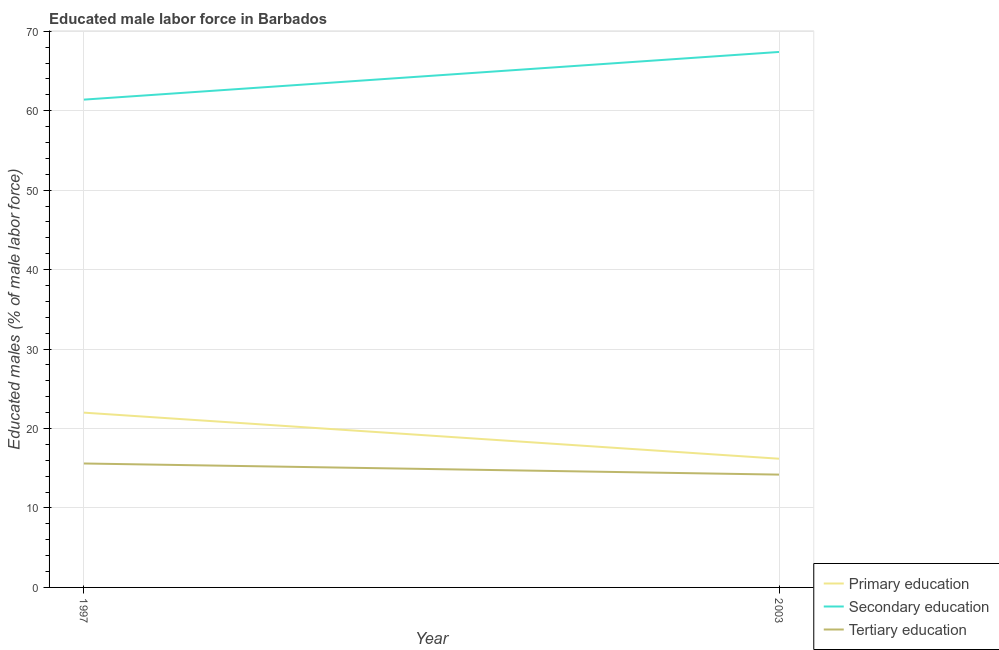Is the number of lines equal to the number of legend labels?
Your answer should be compact. Yes. What is the percentage of male labor force who received tertiary education in 2003?
Ensure brevity in your answer.  14.2. Across all years, what is the maximum percentage of male labor force who received tertiary education?
Your answer should be very brief. 15.6. Across all years, what is the minimum percentage of male labor force who received secondary education?
Your answer should be very brief. 61.4. What is the total percentage of male labor force who received tertiary education in the graph?
Give a very brief answer. 29.8. What is the difference between the percentage of male labor force who received tertiary education in 1997 and that in 2003?
Provide a short and direct response. 1.4. What is the difference between the percentage of male labor force who received secondary education in 1997 and the percentage of male labor force who received primary education in 2003?
Ensure brevity in your answer.  45.2. What is the average percentage of male labor force who received secondary education per year?
Make the answer very short. 64.4. In the year 2003, what is the difference between the percentage of male labor force who received secondary education and percentage of male labor force who received tertiary education?
Make the answer very short. 53.2. In how many years, is the percentage of male labor force who received tertiary education greater than 34 %?
Your answer should be very brief. 0. What is the ratio of the percentage of male labor force who received secondary education in 1997 to that in 2003?
Make the answer very short. 0.91. Is the percentage of male labor force who received tertiary education in 1997 less than that in 2003?
Ensure brevity in your answer.  No. Is the percentage of male labor force who received tertiary education strictly greater than the percentage of male labor force who received primary education over the years?
Offer a very short reply. No. Is the percentage of male labor force who received primary education strictly less than the percentage of male labor force who received secondary education over the years?
Your response must be concise. Yes. How many years are there in the graph?
Your response must be concise. 2. Are the values on the major ticks of Y-axis written in scientific E-notation?
Keep it short and to the point. No. How are the legend labels stacked?
Your answer should be very brief. Vertical. What is the title of the graph?
Give a very brief answer. Educated male labor force in Barbados. Does "Ages 50+" appear as one of the legend labels in the graph?
Your answer should be very brief. No. What is the label or title of the Y-axis?
Make the answer very short. Educated males (% of male labor force). What is the Educated males (% of male labor force) in Primary education in 1997?
Give a very brief answer. 22. What is the Educated males (% of male labor force) in Secondary education in 1997?
Provide a succinct answer. 61.4. What is the Educated males (% of male labor force) in Tertiary education in 1997?
Your response must be concise. 15.6. What is the Educated males (% of male labor force) of Primary education in 2003?
Offer a very short reply. 16.2. What is the Educated males (% of male labor force) in Secondary education in 2003?
Your answer should be very brief. 67.4. What is the Educated males (% of male labor force) of Tertiary education in 2003?
Your answer should be very brief. 14.2. Across all years, what is the maximum Educated males (% of male labor force) of Secondary education?
Provide a short and direct response. 67.4. Across all years, what is the maximum Educated males (% of male labor force) of Tertiary education?
Give a very brief answer. 15.6. Across all years, what is the minimum Educated males (% of male labor force) in Primary education?
Provide a succinct answer. 16.2. Across all years, what is the minimum Educated males (% of male labor force) in Secondary education?
Your answer should be compact. 61.4. Across all years, what is the minimum Educated males (% of male labor force) of Tertiary education?
Your response must be concise. 14.2. What is the total Educated males (% of male labor force) of Primary education in the graph?
Your response must be concise. 38.2. What is the total Educated males (% of male labor force) in Secondary education in the graph?
Your answer should be very brief. 128.8. What is the total Educated males (% of male labor force) in Tertiary education in the graph?
Offer a terse response. 29.8. What is the difference between the Educated males (% of male labor force) in Tertiary education in 1997 and that in 2003?
Ensure brevity in your answer.  1.4. What is the difference between the Educated males (% of male labor force) of Primary education in 1997 and the Educated males (% of male labor force) of Secondary education in 2003?
Ensure brevity in your answer.  -45.4. What is the difference between the Educated males (% of male labor force) in Primary education in 1997 and the Educated males (% of male labor force) in Tertiary education in 2003?
Make the answer very short. 7.8. What is the difference between the Educated males (% of male labor force) in Secondary education in 1997 and the Educated males (% of male labor force) in Tertiary education in 2003?
Ensure brevity in your answer.  47.2. What is the average Educated males (% of male labor force) of Primary education per year?
Your answer should be very brief. 19.1. What is the average Educated males (% of male labor force) in Secondary education per year?
Make the answer very short. 64.4. What is the average Educated males (% of male labor force) in Tertiary education per year?
Offer a very short reply. 14.9. In the year 1997, what is the difference between the Educated males (% of male labor force) in Primary education and Educated males (% of male labor force) in Secondary education?
Your answer should be very brief. -39.4. In the year 1997, what is the difference between the Educated males (% of male labor force) in Primary education and Educated males (% of male labor force) in Tertiary education?
Ensure brevity in your answer.  6.4. In the year 1997, what is the difference between the Educated males (% of male labor force) in Secondary education and Educated males (% of male labor force) in Tertiary education?
Your answer should be compact. 45.8. In the year 2003, what is the difference between the Educated males (% of male labor force) of Primary education and Educated males (% of male labor force) of Secondary education?
Your answer should be very brief. -51.2. In the year 2003, what is the difference between the Educated males (% of male labor force) of Secondary education and Educated males (% of male labor force) of Tertiary education?
Your answer should be very brief. 53.2. What is the ratio of the Educated males (% of male labor force) of Primary education in 1997 to that in 2003?
Give a very brief answer. 1.36. What is the ratio of the Educated males (% of male labor force) of Secondary education in 1997 to that in 2003?
Provide a short and direct response. 0.91. What is the ratio of the Educated males (% of male labor force) of Tertiary education in 1997 to that in 2003?
Give a very brief answer. 1.1. What is the difference between the highest and the second highest Educated males (% of male labor force) of Primary education?
Ensure brevity in your answer.  5.8. What is the difference between the highest and the lowest Educated males (% of male labor force) of Primary education?
Give a very brief answer. 5.8. What is the difference between the highest and the lowest Educated males (% of male labor force) of Secondary education?
Offer a very short reply. 6. What is the difference between the highest and the lowest Educated males (% of male labor force) in Tertiary education?
Your answer should be compact. 1.4. 